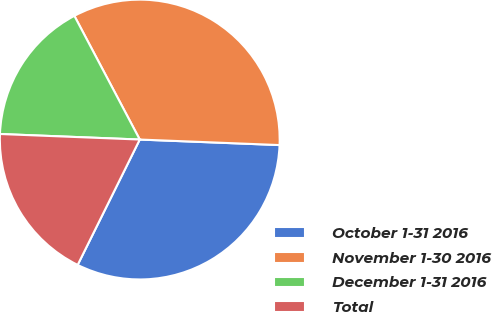<chart> <loc_0><loc_0><loc_500><loc_500><pie_chart><fcel>October 1-31 2016<fcel>November 1-30 2016<fcel>December 1-31 2016<fcel>Total<nl><fcel>31.69%<fcel>33.37%<fcel>16.63%<fcel>18.31%<nl></chart> 